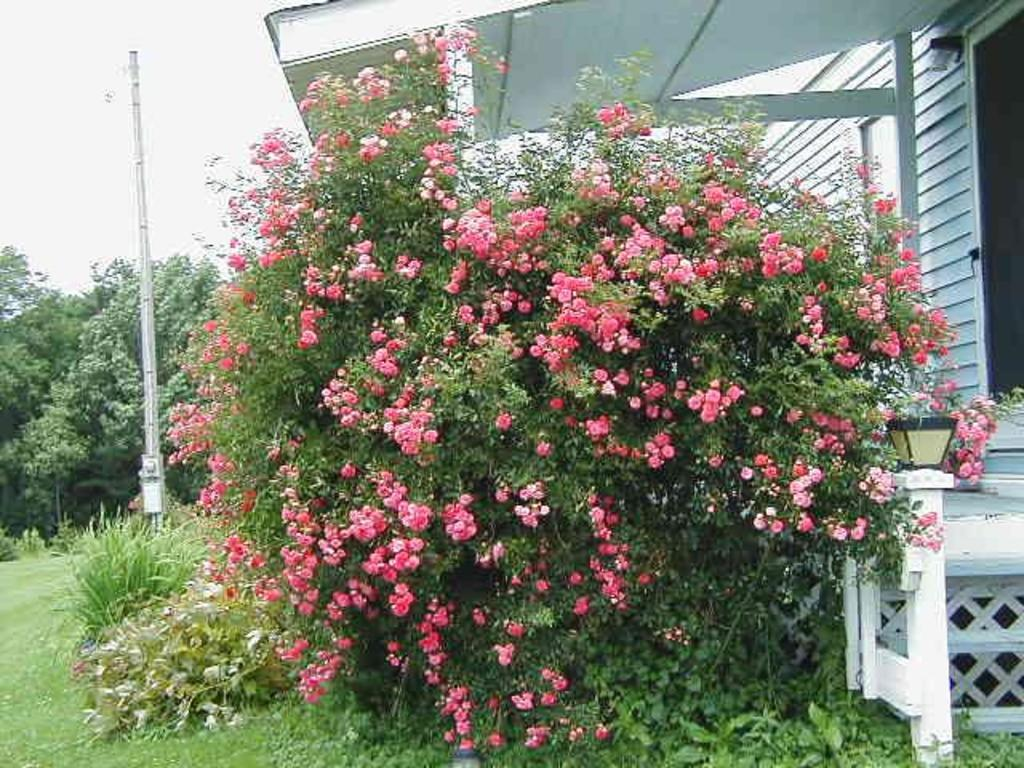What type of plant is visible in the image? There is a plant with flowers in the image. What can be seen on the left side of the image? There is a pole and trees on the left side of the image. What is visible on the left side of the image besides the pole and trees? The sky is visible on the left side of the image. What is located on the right side of the image? There is a house and a lamp on the right side of the image. Can you touch the existence of the rod in the image? There is no rod present in the image, so it cannot be touched or its existence confirmed. 